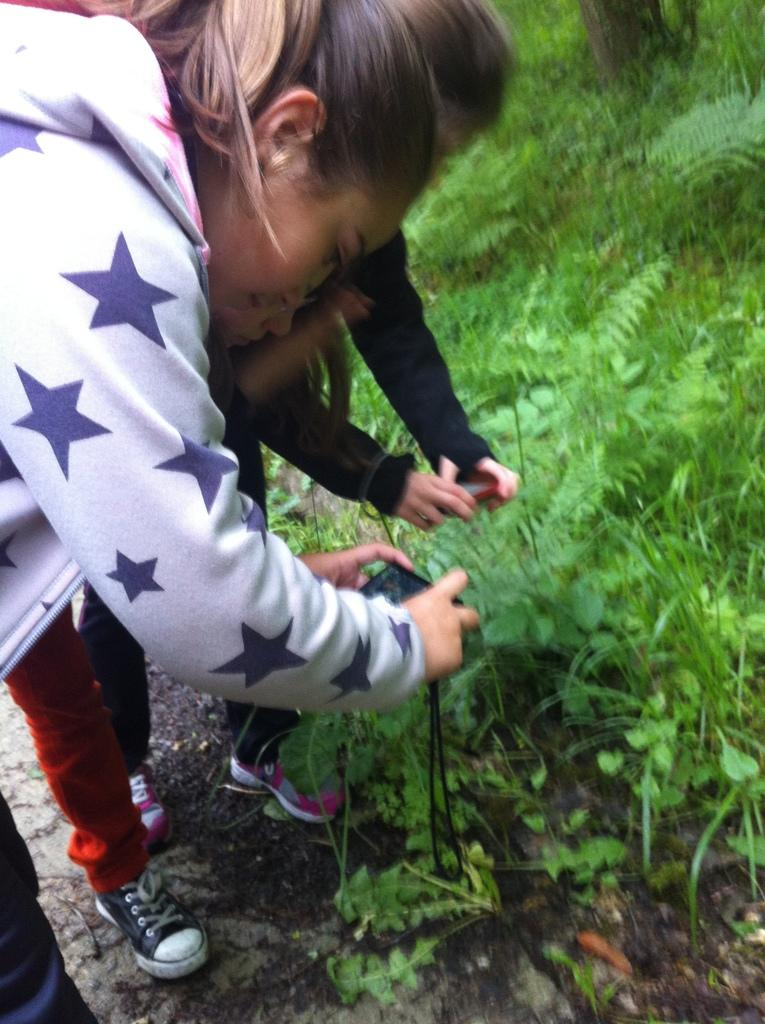Who is present in the image? There are women in the image. What are the women doing in the image? The women are standing on the ground and holding devices. What else can be seen in the image besides the women? There are plants in the image. What type of memory does the kitten have in the image? There is no kitten present in the image, so it is not possible to determine what type of memory it might have. 